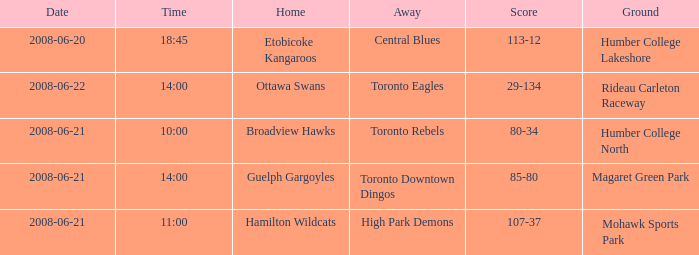What is the Away with a Ground that is humber college lakeshore? Central Blues. 